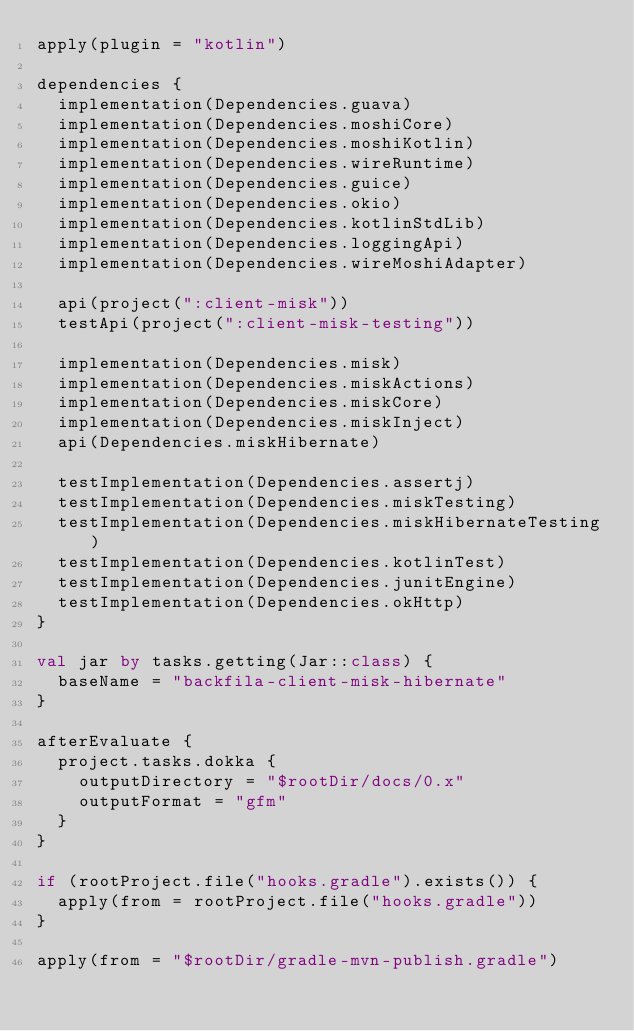Convert code to text. <code><loc_0><loc_0><loc_500><loc_500><_Kotlin_>apply(plugin = "kotlin")

dependencies {
  implementation(Dependencies.guava)
  implementation(Dependencies.moshiCore)
  implementation(Dependencies.moshiKotlin)
  implementation(Dependencies.wireRuntime)
  implementation(Dependencies.guice)
  implementation(Dependencies.okio)
  implementation(Dependencies.kotlinStdLib)
  implementation(Dependencies.loggingApi)
  implementation(Dependencies.wireMoshiAdapter)

  api(project(":client-misk"))
  testApi(project(":client-misk-testing"))

  implementation(Dependencies.misk)
  implementation(Dependencies.miskActions)
  implementation(Dependencies.miskCore)
  implementation(Dependencies.miskInject)
  api(Dependencies.miskHibernate)

  testImplementation(Dependencies.assertj)
  testImplementation(Dependencies.miskTesting)
  testImplementation(Dependencies.miskHibernateTesting)
  testImplementation(Dependencies.kotlinTest)
  testImplementation(Dependencies.junitEngine)
  testImplementation(Dependencies.okHttp)
}

val jar by tasks.getting(Jar::class) {
  baseName = "backfila-client-misk-hibernate"
}

afterEvaluate {
  project.tasks.dokka {
    outputDirectory = "$rootDir/docs/0.x"
    outputFormat = "gfm"
  }
}

if (rootProject.file("hooks.gradle").exists()) {
  apply(from = rootProject.file("hooks.gradle"))
}

apply(from = "$rootDir/gradle-mvn-publish.gradle")</code> 